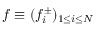Convert formula to latex. <formula><loc_0><loc_0><loc_500><loc_500>f \equiv ( f _ { i } ^ { \pm } ) _ { 1 \leq i \leq N }</formula> 